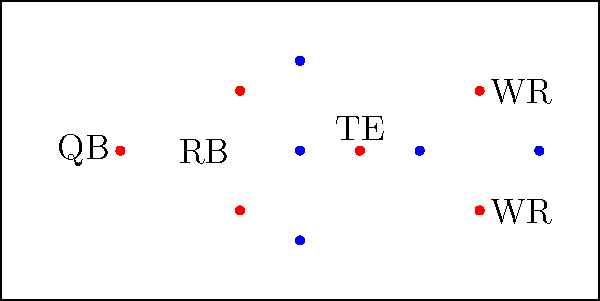Based on the diagram, which offensive formation is depicted? To identify the football formation, let's analyze the positions of the players step-by-step:

1. We see a Quarterback (QB) at the center of the backfield.
2. There's one Running Back (RB) behind the line of scrimmage.
3. We have two Wide Receivers (WR) split out wide on both sides.
4. There's a Tight End (TE) on the line of scrimmage.
5. The formation has five offensive linemen (not labeled but represented by blue dots on the line of scrimmage).

This arrangement of players is characteristic of the "Pro Set" formation. The Pro Set is a common formation in football that provides a balanced offensive look with:

- 1 Quarterback
- 1 Running Back
- 2 Wide Receivers
- 1 Tight End
- 5 Offensive Linemen

The Pro Set offers versatility, allowing for both running and passing plays, making it a staple in many offensive playbooks.
Answer: Pro Set 